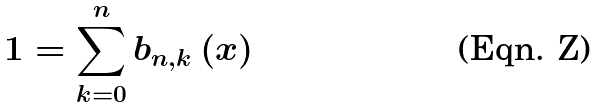Convert formula to latex. <formula><loc_0><loc_0><loc_500><loc_500>1 = \sum _ { k = 0 } ^ { n } b _ { n , k } \left ( x \right )</formula> 